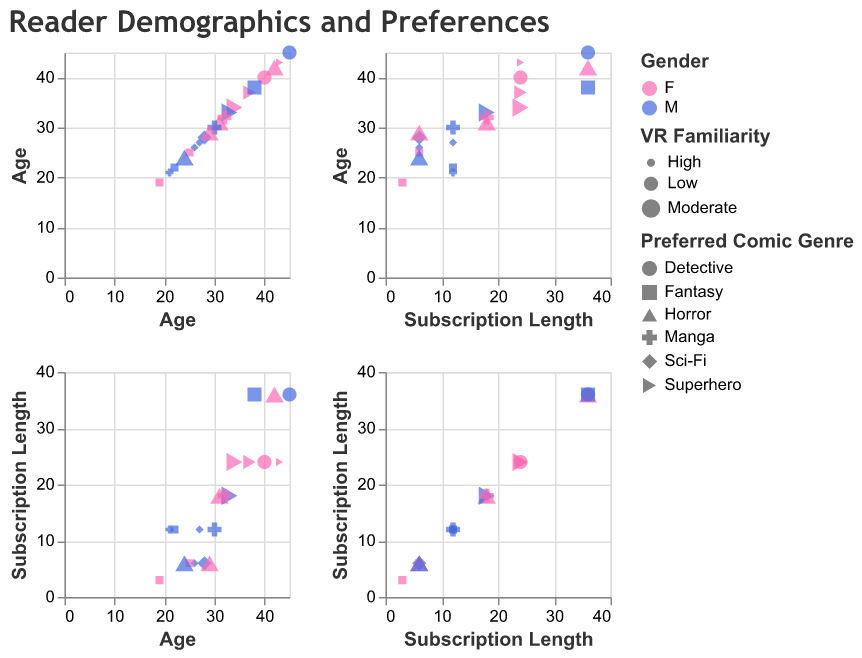What is the title of the figure? The title is usually located at the top of the figure and can be read directly.
Answer: Reader Demographics and Preferences How many data points are there in the entire dataset? Count the number of points visible in the scatter plots. Each data point represents an individual entry.
Answer: 20 What shapes are used to represent different comic genres? Check the legend or the point shapes within the scatter plots to identify how different genres are represented.
Answer: Various shapes Which gender has the highest average subscription length? Visualize the average length for each gender by looking at the distribution of points colored by gender across the subscription length axis. Calculate the average for each.
Answer: Males Which VR familiarity level is associated with the largest marker size? Observe the legend or the visualization and see which VR Familiarity level corresponds to the largest markers.
Answer: High Is there a visible trend between age and subscription length? Analyze the scatter plot for a correlation pattern between age (x-axis) and subscription length (y-axis).
Answer: No clear trend Which preferred comic genre appears most frequently among male readers? Look at the shapes of the points colored blue (male) and count the occurrences for each genre.
Answer: Sci-Fi What's the most common VR Familiarity level among female readers aged between 30 and 40? Focus on the subset of the plot where age is between 30 and 40, filter by pink points (female), and identify the most frequent VR Familiarity level.
Answer: Moderate For readers with high VR Familiarity, which age group seems to be more prevalent? Look at the largest markers (representing high VR Familiarity) and identify the common age ranges.
Answer: 20-30 How do the subscription lengths compare between readers who prefer Horror and those who prefer Manga? Compare the distribution of subscription lengths (y-axis) for points shaped according to Horror versus Manga genres.
Answer: Horror tends to have shorter subscription lengths than Manga 